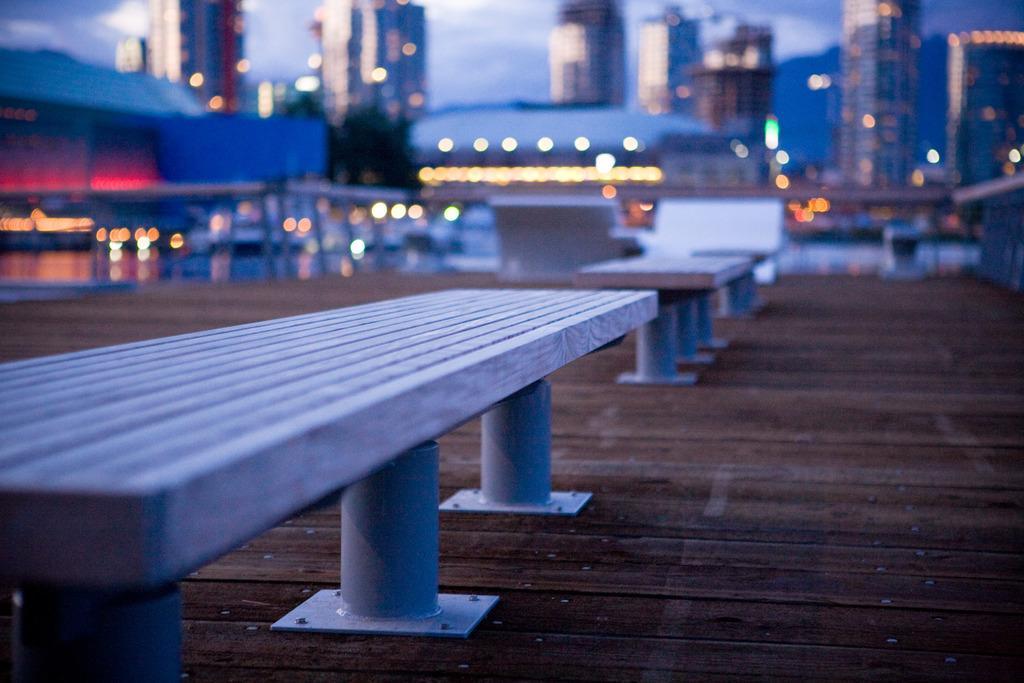How would you summarize this image in a sentence or two? In this image I can see some benches on the wooden surface. In the background I can see many buildings, lights and the sky. I can see the background is blurred. 